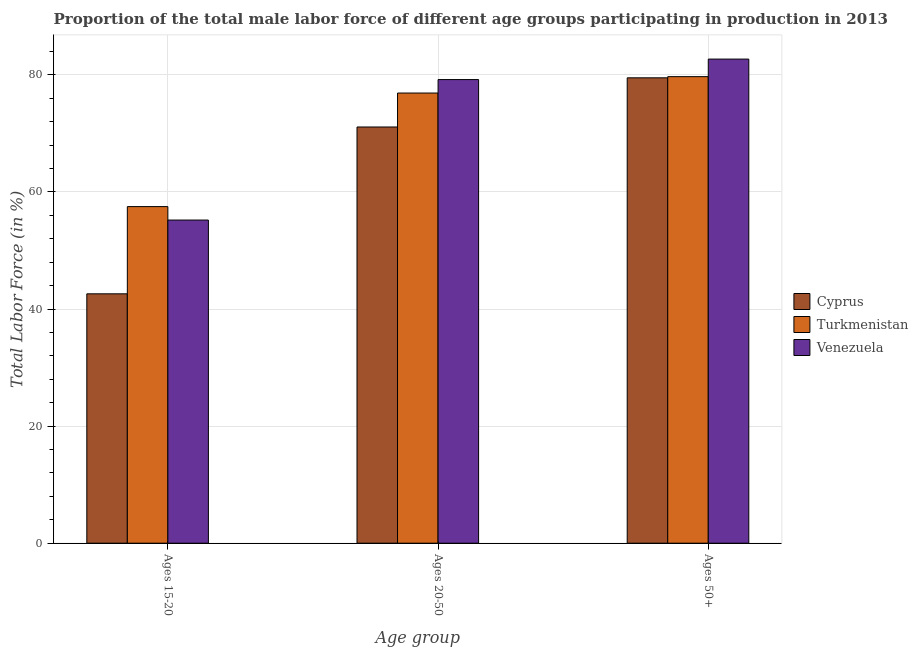What is the label of the 3rd group of bars from the left?
Provide a short and direct response. Ages 50+. What is the percentage of male labor force within the age group 20-50 in Cyprus?
Your answer should be compact. 71.1. Across all countries, what is the maximum percentage of male labor force above age 50?
Offer a very short reply. 82.7. Across all countries, what is the minimum percentage of male labor force above age 50?
Offer a very short reply. 79.5. In which country was the percentage of male labor force above age 50 maximum?
Provide a succinct answer. Venezuela. In which country was the percentage of male labor force above age 50 minimum?
Ensure brevity in your answer.  Cyprus. What is the total percentage of male labor force within the age group 20-50 in the graph?
Provide a succinct answer. 227.2. What is the difference between the percentage of male labor force within the age group 15-20 in Cyprus and that in Venezuela?
Offer a very short reply. -12.6. What is the difference between the percentage of male labor force within the age group 15-20 in Cyprus and the percentage of male labor force within the age group 20-50 in Venezuela?
Offer a terse response. -36.6. What is the average percentage of male labor force within the age group 20-50 per country?
Provide a short and direct response. 75.73. What is the difference between the percentage of male labor force within the age group 15-20 and percentage of male labor force above age 50 in Cyprus?
Provide a short and direct response. -36.9. What is the ratio of the percentage of male labor force within the age group 15-20 in Turkmenistan to that in Venezuela?
Your response must be concise. 1.04. Is the difference between the percentage of male labor force above age 50 in Cyprus and Turkmenistan greater than the difference between the percentage of male labor force within the age group 20-50 in Cyprus and Turkmenistan?
Provide a succinct answer. Yes. What is the difference between the highest and the second highest percentage of male labor force within the age group 15-20?
Your answer should be compact. 2.3. What is the difference between the highest and the lowest percentage of male labor force within the age group 15-20?
Your response must be concise. 14.9. Is the sum of the percentage of male labor force within the age group 20-50 in Turkmenistan and Venezuela greater than the maximum percentage of male labor force within the age group 15-20 across all countries?
Keep it short and to the point. Yes. What does the 3rd bar from the left in Ages 50+ represents?
Make the answer very short. Venezuela. What does the 3rd bar from the right in Ages 15-20 represents?
Make the answer very short. Cyprus. Is it the case that in every country, the sum of the percentage of male labor force within the age group 15-20 and percentage of male labor force within the age group 20-50 is greater than the percentage of male labor force above age 50?
Ensure brevity in your answer.  Yes. How many bars are there?
Your answer should be compact. 9. Are the values on the major ticks of Y-axis written in scientific E-notation?
Keep it short and to the point. No. How many legend labels are there?
Give a very brief answer. 3. What is the title of the graph?
Offer a very short reply. Proportion of the total male labor force of different age groups participating in production in 2013. Does "Uzbekistan" appear as one of the legend labels in the graph?
Offer a terse response. No. What is the label or title of the X-axis?
Offer a terse response. Age group. What is the label or title of the Y-axis?
Provide a succinct answer. Total Labor Force (in %). What is the Total Labor Force (in %) in Cyprus in Ages 15-20?
Give a very brief answer. 42.6. What is the Total Labor Force (in %) in Turkmenistan in Ages 15-20?
Make the answer very short. 57.5. What is the Total Labor Force (in %) in Venezuela in Ages 15-20?
Ensure brevity in your answer.  55.2. What is the Total Labor Force (in %) in Cyprus in Ages 20-50?
Keep it short and to the point. 71.1. What is the Total Labor Force (in %) in Turkmenistan in Ages 20-50?
Give a very brief answer. 76.9. What is the Total Labor Force (in %) in Venezuela in Ages 20-50?
Provide a succinct answer. 79.2. What is the Total Labor Force (in %) in Cyprus in Ages 50+?
Your answer should be very brief. 79.5. What is the Total Labor Force (in %) of Turkmenistan in Ages 50+?
Provide a succinct answer. 79.7. What is the Total Labor Force (in %) in Venezuela in Ages 50+?
Give a very brief answer. 82.7. Across all Age group, what is the maximum Total Labor Force (in %) of Cyprus?
Keep it short and to the point. 79.5. Across all Age group, what is the maximum Total Labor Force (in %) in Turkmenistan?
Your answer should be very brief. 79.7. Across all Age group, what is the maximum Total Labor Force (in %) of Venezuela?
Ensure brevity in your answer.  82.7. Across all Age group, what is the minimum Total Labor Force (in %) of Cyprus?
Your answer should be compact. 42.6. Across all Age group, what is the minimum Total Labor Force (in %) in Turkmenistan?
Offer a very short reply. 57.5. Across all Age group, what is the minimum Total Labor Force (in %) of Venezuela?
Keep it short and to the point. 55.2. What is the total Total Labor Force (in %) of Cyprus in the graph?
Your response must be concise. 193.2. What is the total Total Labor Force (in %) of Turkmenistan in the graph?
Your answer should be very brief. 214.1. What is the total Total Labor Force (in %) of Venezuela in the graph?
Offer a terse response. 217.1. What is the difference between the Total Labor Force (in %) in Cyprus in Ages 15-20 and that in Ages 20-50?
Provide a short and direct response. -28.5. What is the difference between the Total Labor Force (in %) of Turkmenistan in Ages 15-20 and that in Ages 20-50?
Provide a short and direct response. -19.4. What is the difference between the Total Labor Force (in %) in Cyprus in Ages 15-20 and that in Ages 50+?
Keep it short and to the point. -36.9. What is the difference between the Total Labor Force (in %) in Turkmenistan in Ages 15-20 and that in Ages 50+?
Provide a short and direct response. -22.2. What is the difference between the Total Labor Force (in %) in Venezuela in Ages 15-20 and that in Ages 50+?
Your answer should be very brief. -27.5. What is the difference between the Total Labor Force (in %) in Cyprus in Ages 20-50 and that in Ages 50+?
Ensure brevity in your answer.  -8.4. What is the difference between the Total Labor Force (in %) of Venezuela in Ages 20-50 and that in Ages 50+?
Provide a succinct answer. -3.5. What is the difference between the Total Labor Force (in %) in Cyprus in Ages 15-20 and the Total Labor Force (in %) in Turkmenistan in Ages 20-50?
Ensure brevity in your answer.  -34.3. What is the difference between the Total Labor Force (in %) of Cyprus in Ages 15-20 and the Total Labor Force (in %) of Venezuela in Ages 20-50?
Provide a short and direct response. -36.6. What is the difference between the Total Labor Force (in %) of Turkmenistan in Ages 15-20 and the Total Labor Force (in %) of Venezuela in Ages 20-50?
Provide a short and direct response. -21.7. What is the difference between the Total Labor Force (in %) of Cyprus in Ages 15-20 and the Total Labor Force (in %) of Turkmenistan in Ages 50+?
Provide a succinct answer. -37.1. What is the difference between the Total Labor Force (in %) in Cyprus in Ages 15-20 and the Total Labor Force (in %) in Venezuela in Ages 50+?
Your answer should be very brief. -40.1. What is the difference between the Total Labor Force (in %) in Turkmenistan in Ages 15-20 and the Total Labor Force (in %) in Venezuela in Ages 50+?
Provide a succinct answer. -25.2. What is the difference between the Total Labor Force (in %) in Cyprus in Ages 20-50 and the Total Labor Force (in %) in Turkmenistan in Ages 50+?
Give a very brief answer. -8.6. What is the difference between the Total Labor Force (in %) in Cyprus in Ages 20-50 and the Total Labor Force (in %) in Venezuela in Ages 50+?
Your response must be concise. -11.6. What is the average Total Labor Force (in %) in Cyprus per Age group?
Offer a terse response. 64.4. What is the average Total Labor Force (in %) of Turkmenistan per Age group?
Your answer should be very brief. 71.37. What is the average Total Labor Force (in %) of Venezuela per Age group?
Ensure brevity in your answer.  72.37. What is the difference between the Total Labor Force (in %) in Cyprus and Total Labor Force (in %) in Turkmenistan in Ages 15-20?
Make the answer very short. -14.9. What is the difference between the Total Labor Force (in %) of Cyprus and Total Labor Force (in %) of Venezuela in Ages 20-50?
Offer a terse response. -8.1. What is the difference between the Total Labor Force (in %) in Turkmenistan and Total Labor Force (in %) in Venezuela in Ages 20-50?
Offer a very short reply. -2.3. What is the difference between the Total Labor Force (in %) of Cyprus and Total Labor Force (in %) of Turkmenistan in Ages 50+?
Your response must be concise. -0.2. What is the ratio of the Total Labor Force (in %) in Cyprus in Ages 15-20 to that in Ages 20-50?
Keep it short and to the point. 0.6. What is the ratio of the Total Labor Force (in %) in Turkmenistan in Ages 15-20 to that in Ages 20-50?
Give a very brief answer. 0.75. What is the ratio of the Total Labor Force (in %) of Venezuela in Ages 15-20 to that in Ages 20-50?
Offer a terse response. 0.7. What is the ratio of the Total Labor Force (in %) in Cyprus in Ages 15-20 to that in Ages 50+?
Provide a short and direct response. 0.54. What is the ratio of the Total Labor Force (in %) of Turkmenistan in Ages 15-20 to that in Ages 50+?
Your response must be concise. 0.72. What is the ratio of the Total Labor Force (in %) in Venezuela in Ages 15-20 to that in Ages 50+?
Give a very brief answer. 0.67. What is the ratio of the Total Labor Force (in %) of Cyprus in Ages 20-50 to that in Ages 50+?
Keep it short and to the point. 0.89. What is the ratio of the Total Labor Force (in %) of Turkmenistan in Ages 20-50 to that in Ages 50+?
Provide a succinct answer. 0.96. What is the ratio of the Total Labor Force (in %) in Venezuela in Ages 20-50 to that in Ages 50+?
Your answer should be very brief. 0.96. What is the difference between the highest and the second highest Total Labor Force (in %) of Venezuela?
Make the answer very short. 3.5. What is the difference between the highest and the lowest Total Labor Force (in %) in Cyprus?
Keep it short and to the point. 36.9. What is the difference between the highest and the lowest Total Labor Force (in %) in Turkmenistan?
Make the answer very short. 22.2. What is the difference between the highest and the lowest Total Labor Force (in %) in Venezuela?
Offer a very short reply. 27.5. 